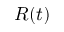<formula> <loc_0><loc_0><loc_500><loc_500>R ( t )</formula> 